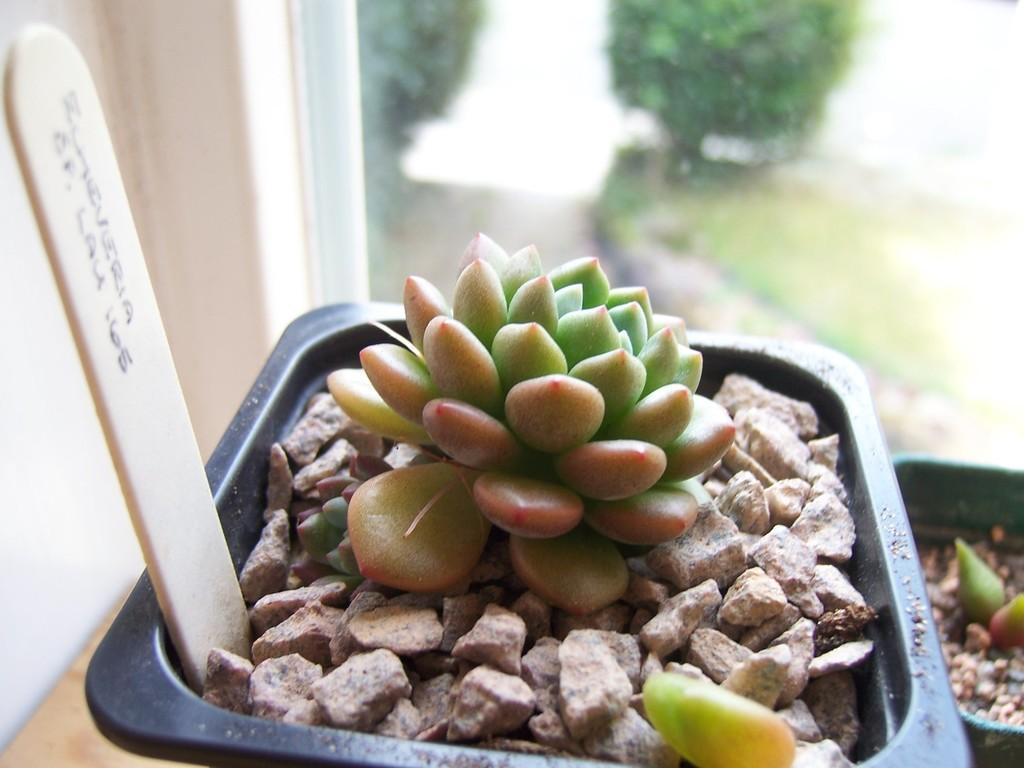In one or two sentences, can you explain what this image depicts? In the foreground I can see houseplants, stones and a stick. In the background I can see a window, trees and a wall. This image is taken, may be in a room. 